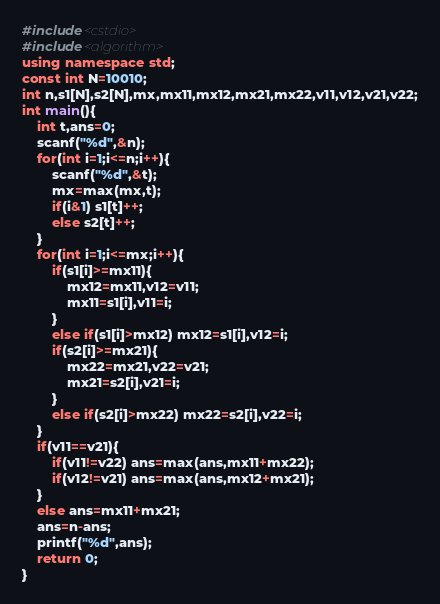Convert code to text. <code><loc_0><loc_0><loc_500><loc_500><_C++_>#include<cstdio>
#include<algorithm>
using namespace std;
const int N=10010;
int n,s1[N],s2[N],mx,mx11,mx12,mx21,mx22,v11,v12,v21,v22;
int main(){
	int t,ans=0;
	scanf("%d",&n);
	for(int i=1;i<=n;i++){
		scanf("%d",&t);
		mx=max(mx,t);
		if(i&1) s1[t]++;
		else s2[t]++;
	}
	for(int i=1;i<=mx;i++){
		if(s1[i]>=mx11){
			mx12=mx11,v12=v11;
			mx11=s1[i],v11=i;
		}
		else if(s1[i]>mx12) mx12=s1[i],v12=i;
		if(s2[i]>=mx21){
			mx22=mx21,v22=v21;
			mx21=s2[i],v21=i;
		}
		else if(s2[i]>mx22) mx22=s2[i],v22=i;
	}
	if(v11==v21){
		if(v11!=v22) ans=max(ans,mx11+mx22);
		if(v12!=v21) ans=max(ans,mx12+mx21);
	}
	else ans=mx11+mx21;
	ans=n-ans;
	printf("%d",ans);
	return 0;
} </code> 